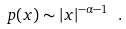Convert formula to latex. <formula><loc_0><loc_0><loc_500><loc_500>p ( x ) \sim | x | ^ { - \alpha - 1 } \ .</formula> 